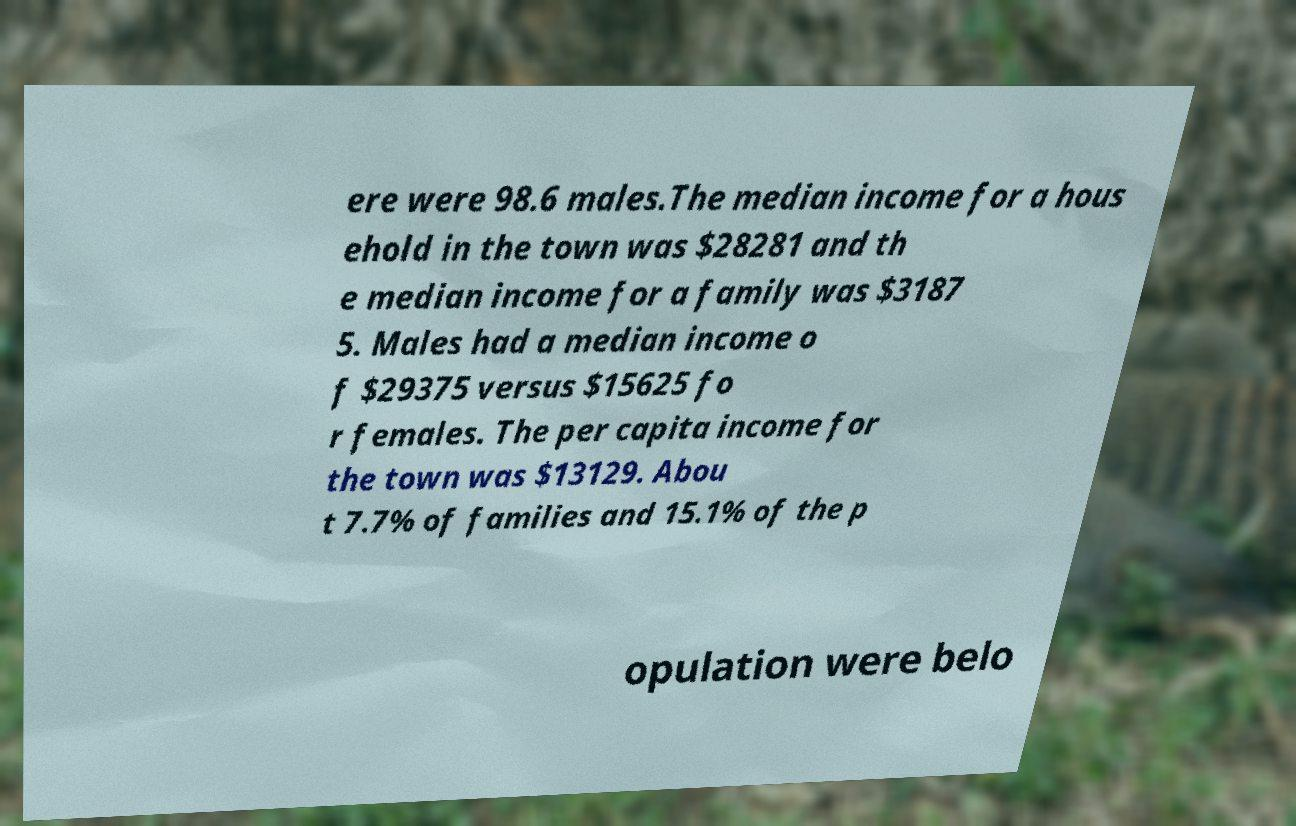What messages or text are displayed in this image? I need them in a readable, typed format. ere were 98.6 males.The median income for a hous ehold in the town was $28281 and th e median income for a family was $3187 5. Males had a median income o f $29375 versus $15625 fo r females. The per capita income for the town was $13129. Abou t 7.7% of families and 15.1% of the p opulation were belo 